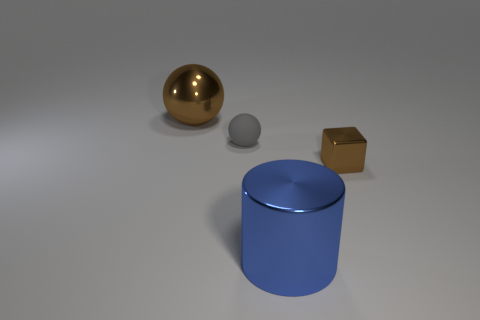Can you describe the lighting condition in the scene? The scene is illuminated by diffuse lighting, generating soft shadows. It does not appear to have a direct light source, such as the sun, but rather ambient light that is giving the objects a gentle and even lighting with subtle shadows. This could imply an indoor setting or a studio environment with controlled lighting. 